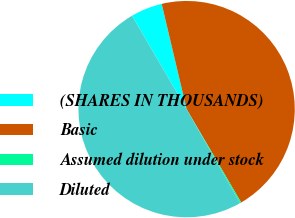Convert chart to OTSL. <chart><loc_0><loc_0><loc_500><loc_500><pie_chart><fcel>(SHARES IN THOUSANDS)<fcel>Basic<fcel>Assumed dilution under stock<fcel>Diluted<nl><fcel>4.72%<fcel>45.28%<fcel>0.19%<fcel>49.81%<nl></chart> 